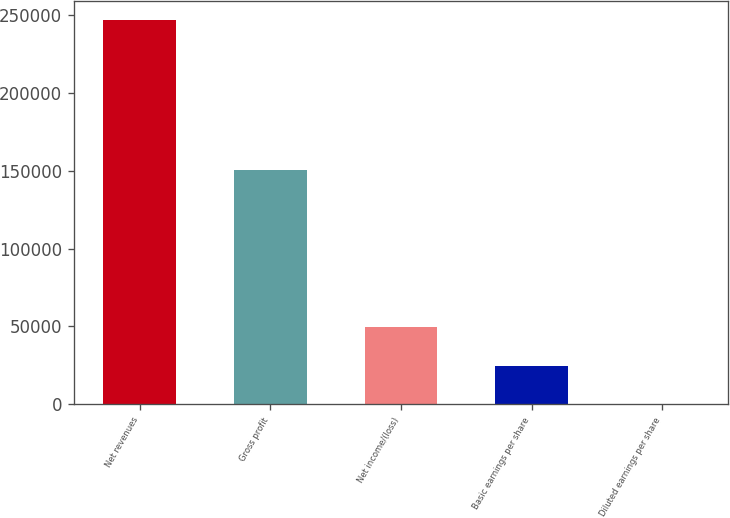Convert chart to OTSL. <chart><loc_0><loc_0><loc_500><loc_500><bar_chart><fcel>Net revenues<fcel>Gross profit<fcel>Net income/(loss)<fcel>Basic earnings per share<fcel>Diluted earnings per share<nl><fcel>246992<fcel>150178<fcel>49398.8<fcel>24699.7<fcel>0.55<nl></chart> 